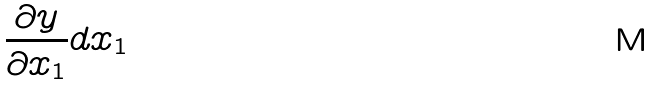Convert formula to latex. <formula><loc_0><loc_0><loc_500><loc_500>\frac { \partial y } { \partial x _ { 1 } } d x _ { 1 }</formula> 